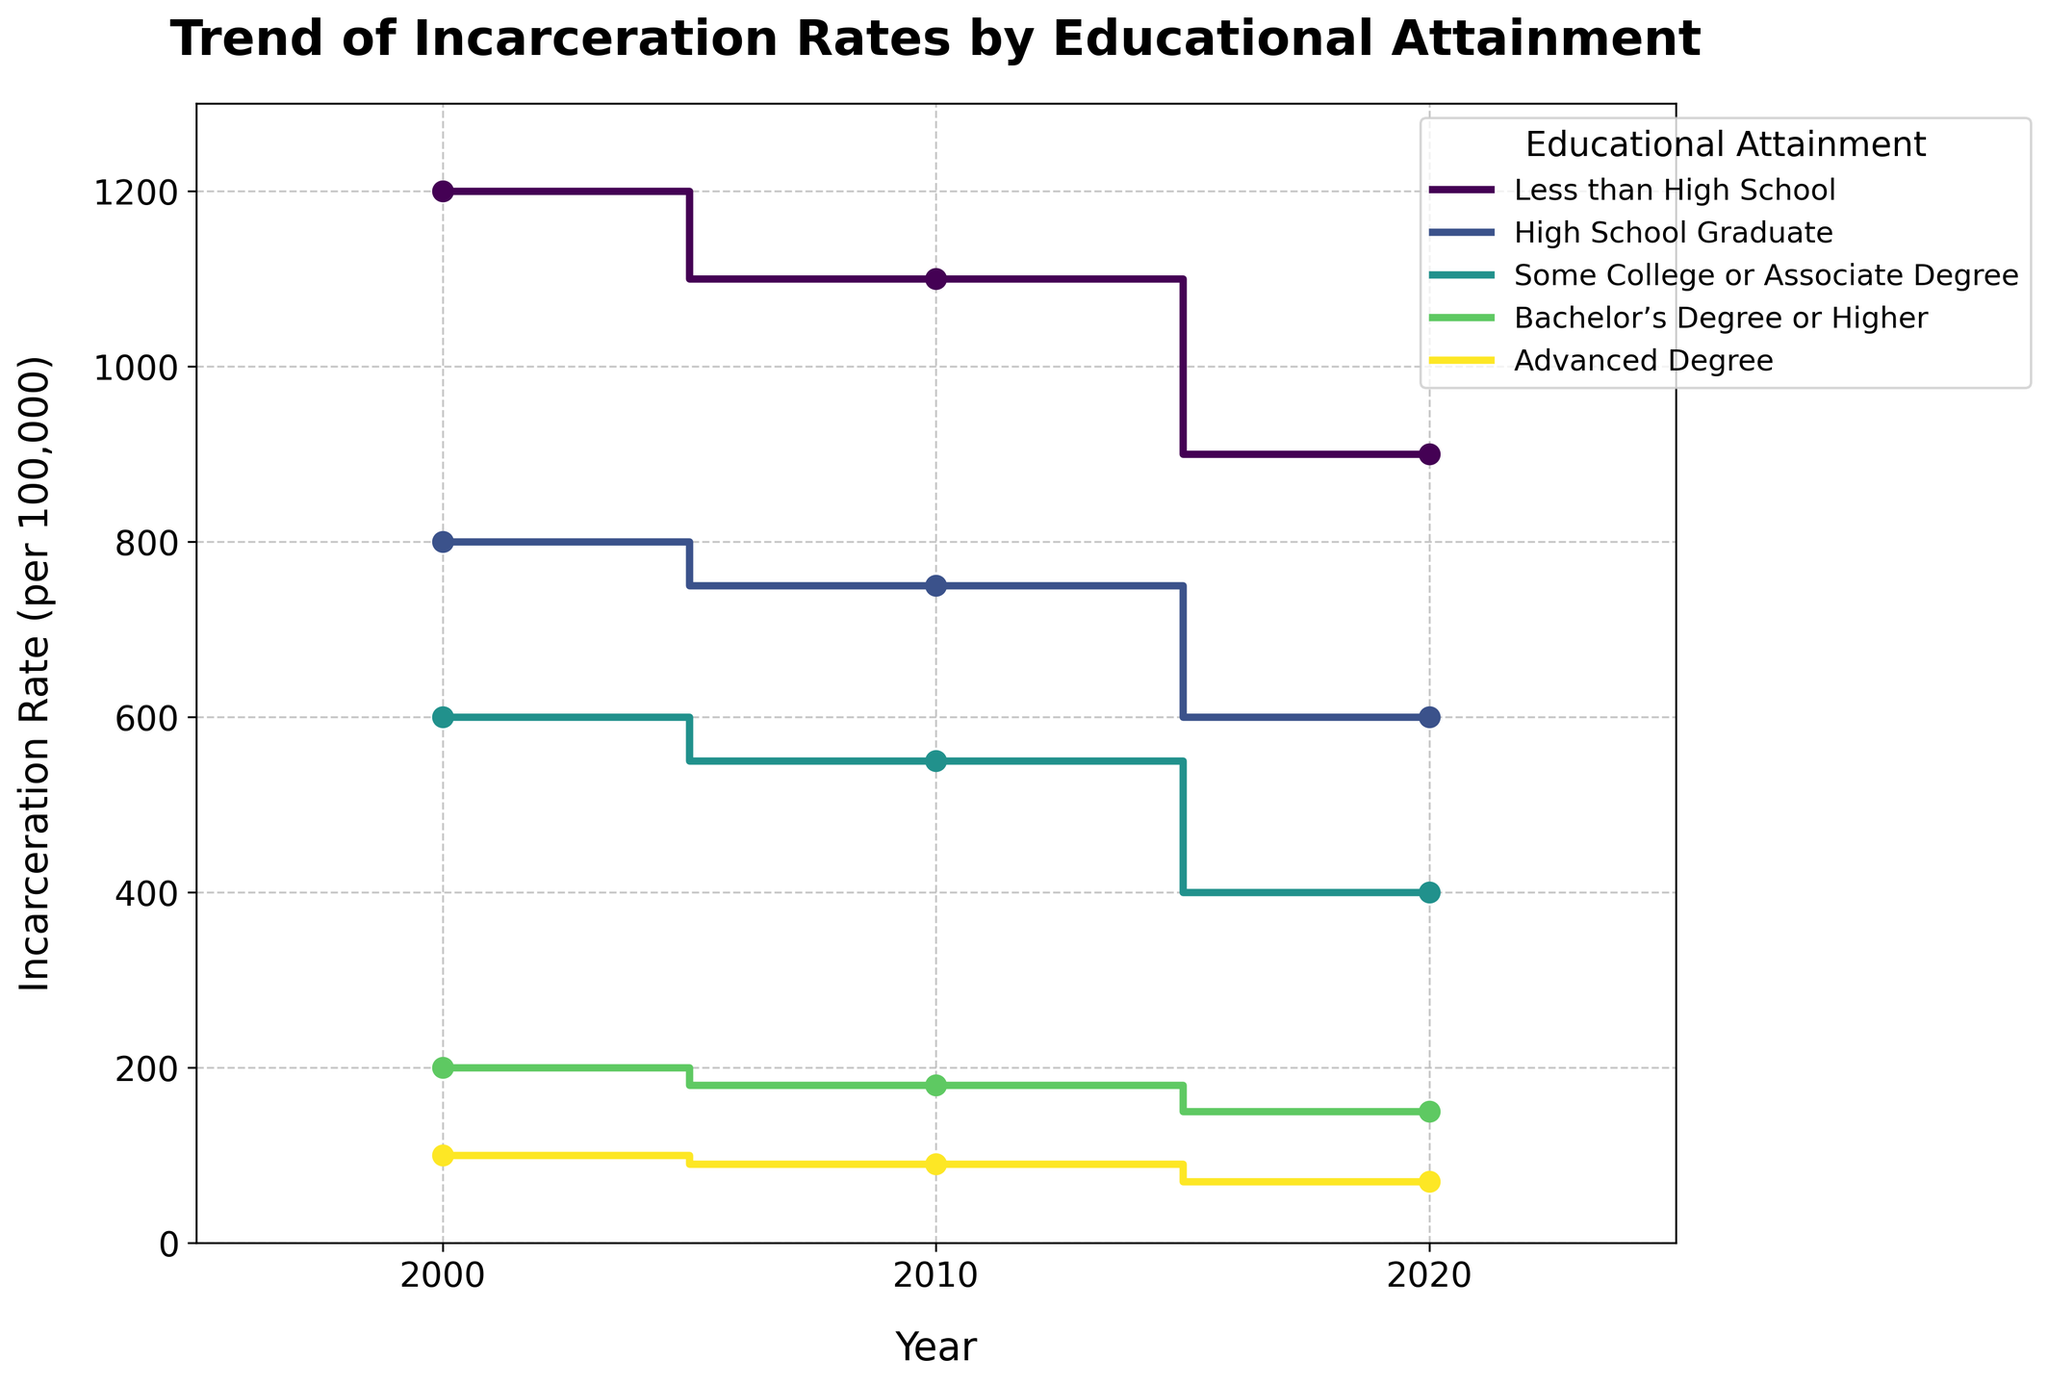What is the title of the figure? The title is displayed at the top of the figure. By reading it, we can determine the title of the figure.
Answer: Trend of Incarceration Rates by Educational Attainment What years are represented on the x-axis in the figure? The x-axis lists the years at which the data points are recorded. The labels indicate the specific years.
Answer: 2000, 2010, 2020 Which educational attainment level had the highest incarceration rate in 2000? By looking at the values plotted for the year 2000 for each educational attainment level, we can identify the highest value.
Answer: Less than High School How did the incarceration rate for those with an Advanced Degree change from 2000 to 2020? We compare the values for people with an Advanced Degree in 2000 and 2020 to see the change. This involves noting the rate in 2000 and observing the rate in 2020.
Answer: It decreased from 100 to 70 What is the general trend of the incarceration rates for all educational levels over time? Observing the overall direction of the lines for each educational level, we can identify if they are increasing, decreasing, or remaining stable over the years.
Answer: Decreasing Among the different educational attainment levels, which saw the greatest reduction in incarceration rates from 2000 to 2020? We calculate the reduction for each educational level by subtracting the 2020 rates from the 2000 rates and identify the level with the largest difference.
Answer: Less than High School Which educational attainment level had the lowest incarceration rate in 2020? By checking the plotted rates for each educational level in 2020, we can determine the lowest rate.
Answer: Advanced Degree Did the incarceration rate for High School Graduates ever exceed 800 over the years displayed? We need to check the values for High School Graduates in 2000, 2010, and 2020 to see if any rate is above 800.
Answer: No What is the average incarceration rate for those with Some College or an Associate Degree across the three years? To find the average, we sum the incarceration rates in 2000, 2010, and 2020 for this level and divide by the number of years (3).
Answer: 516.67 Which two educational attainment levels had the closest incarceration rates in 2020? We compare the 2020 rates of each pair of educational levels and find the smallest difference to determine the closest rates.
Answer: Bachelor’s Degree or Higher and Advanced Degree 